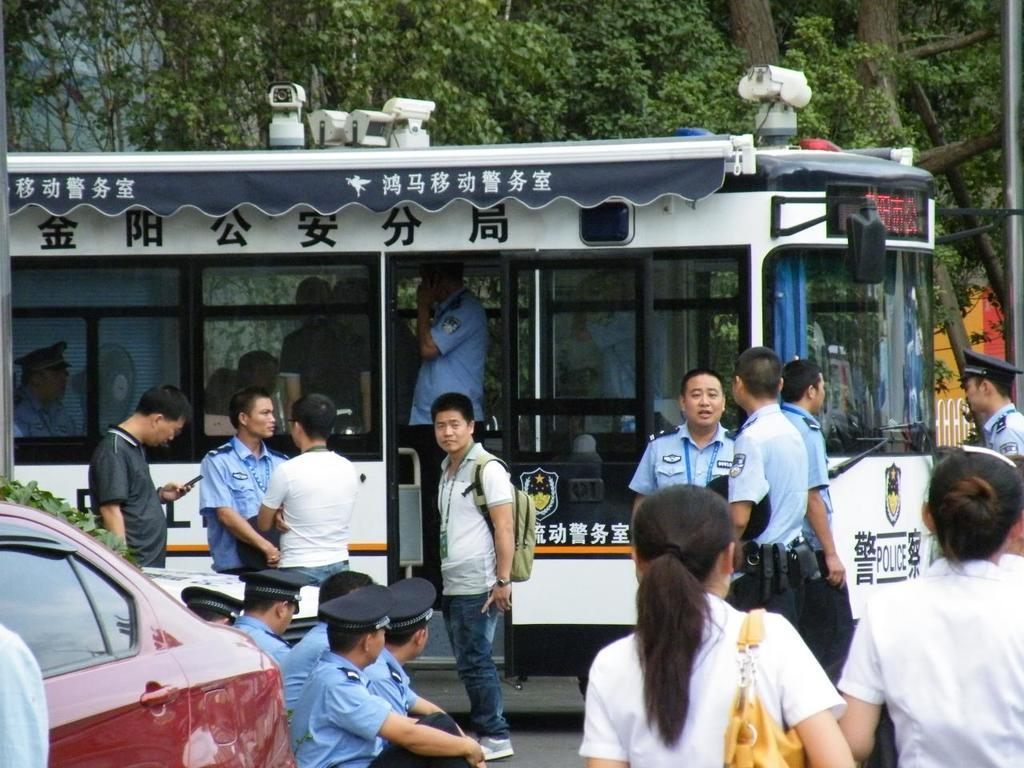<image>
Summarize the visual content of the image. people standing in front of a trolley that says 'police' at the front of it 